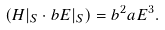Convert formula to latex. <formula><loc_0><loc_0><loc_500><loc_500>( H | _ { S } \cdot b E | _ { S } ) = b ^ { 2 } a E ^ { 3 } .</formula> 